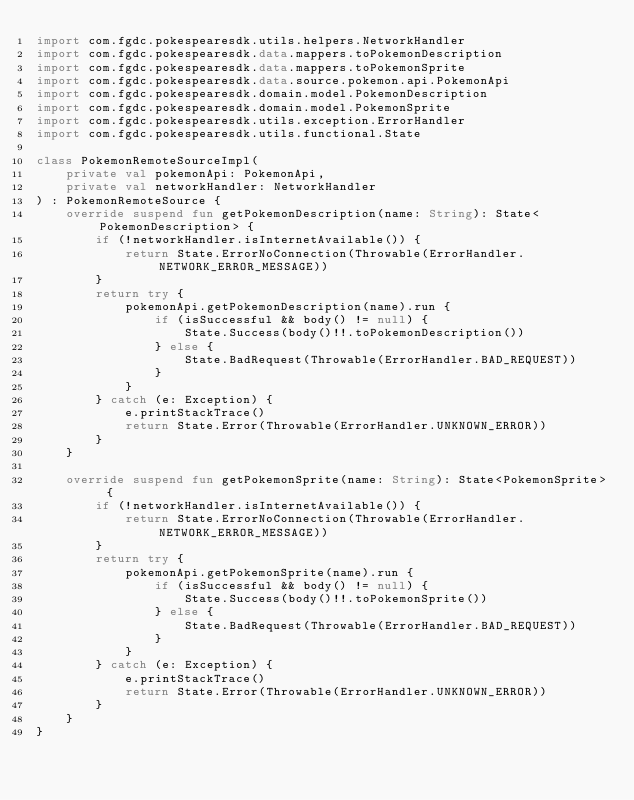<code> <loc_0><loc_0><loc_500><loc_500><_Kotlin_>import com.fgdc.pokespearesdk.utils.helpers.NetworkHandler
import com.fgdc.pokespearesdk.data.mappers.toPokemonDescription
import com.fgdc.pokespearesdk.data.mappers.toPokemonSprite
import com.fgdc.pokespearesdk.data.source.pokemon.api.PokemonApi
import com.fgdc.pokespearesdk.domain.model.PokemonDescription
import com.fgdc.pokespearesdk.domain.model.PokemonSprite
import com.fgdc.pokespearesdk.utils.exception.ErrorHandler
import com.fgdc.pokespearesdk.utils.functional.State

class PokemonRemoteSourceImpl(
    private val pokemonApi: PokemonApi,
    private val networkHandler: NetworkHandler
) : PokemonRemoteSource {
    override suspend fun getPokemonDescription(name: String): State<PokemonDescription> {
        if (!networkHandler.isInternetAvailable()) {
            return State.ErrorNoConnection(Throwable(ErrorHandler.NETWORK_ERROR_MESSAGE))
        }
        return try {
            pokemonApi.getPokemonDescription(name).run {
                if (isSuccessful && body() != null) {
                    State.Success(body()!!.toPokemonDescription())
                } else {
                    State.BadRequest(Throwable(ErrorHandler.BAD_REQUEST))
                }
            }
        } catch (e: Exception) {
            e.printStackTrace()
            return State.Error(Throwable(ErrorHandler.UNKNOWN_ERROR))
        }
    }

    override suspend fun getPokemonSprite(name: String): State<PokemonSprite> {
        if (!networkHandler.isInternetAvailable()) {
            return State.ErrorNoConnection(Throwable(ErrorHandler.NETWORK_ERROR_MESSAGE))
        }
        return try {
            pokemonApi.getPokemonSprite(name).run {
                if (isSuccessful && body() != null) {
                    State.Success(body()!!.toPokemonSprite())
                } else {
                    State.BadRequest(Throwable(ErrorHandler.BAD_REQUEST))
                }
            }
        } catch (e: Exception) {
            e.printStackTrace()
            return State.Error(Throwable(ErrorHandler.UNKNOWN_ERROR))
        }
    }
}
</code> 